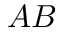Convert formula to latex. <formula><loc_0><loc_0><loc_500><loc_500>A B</formula> 